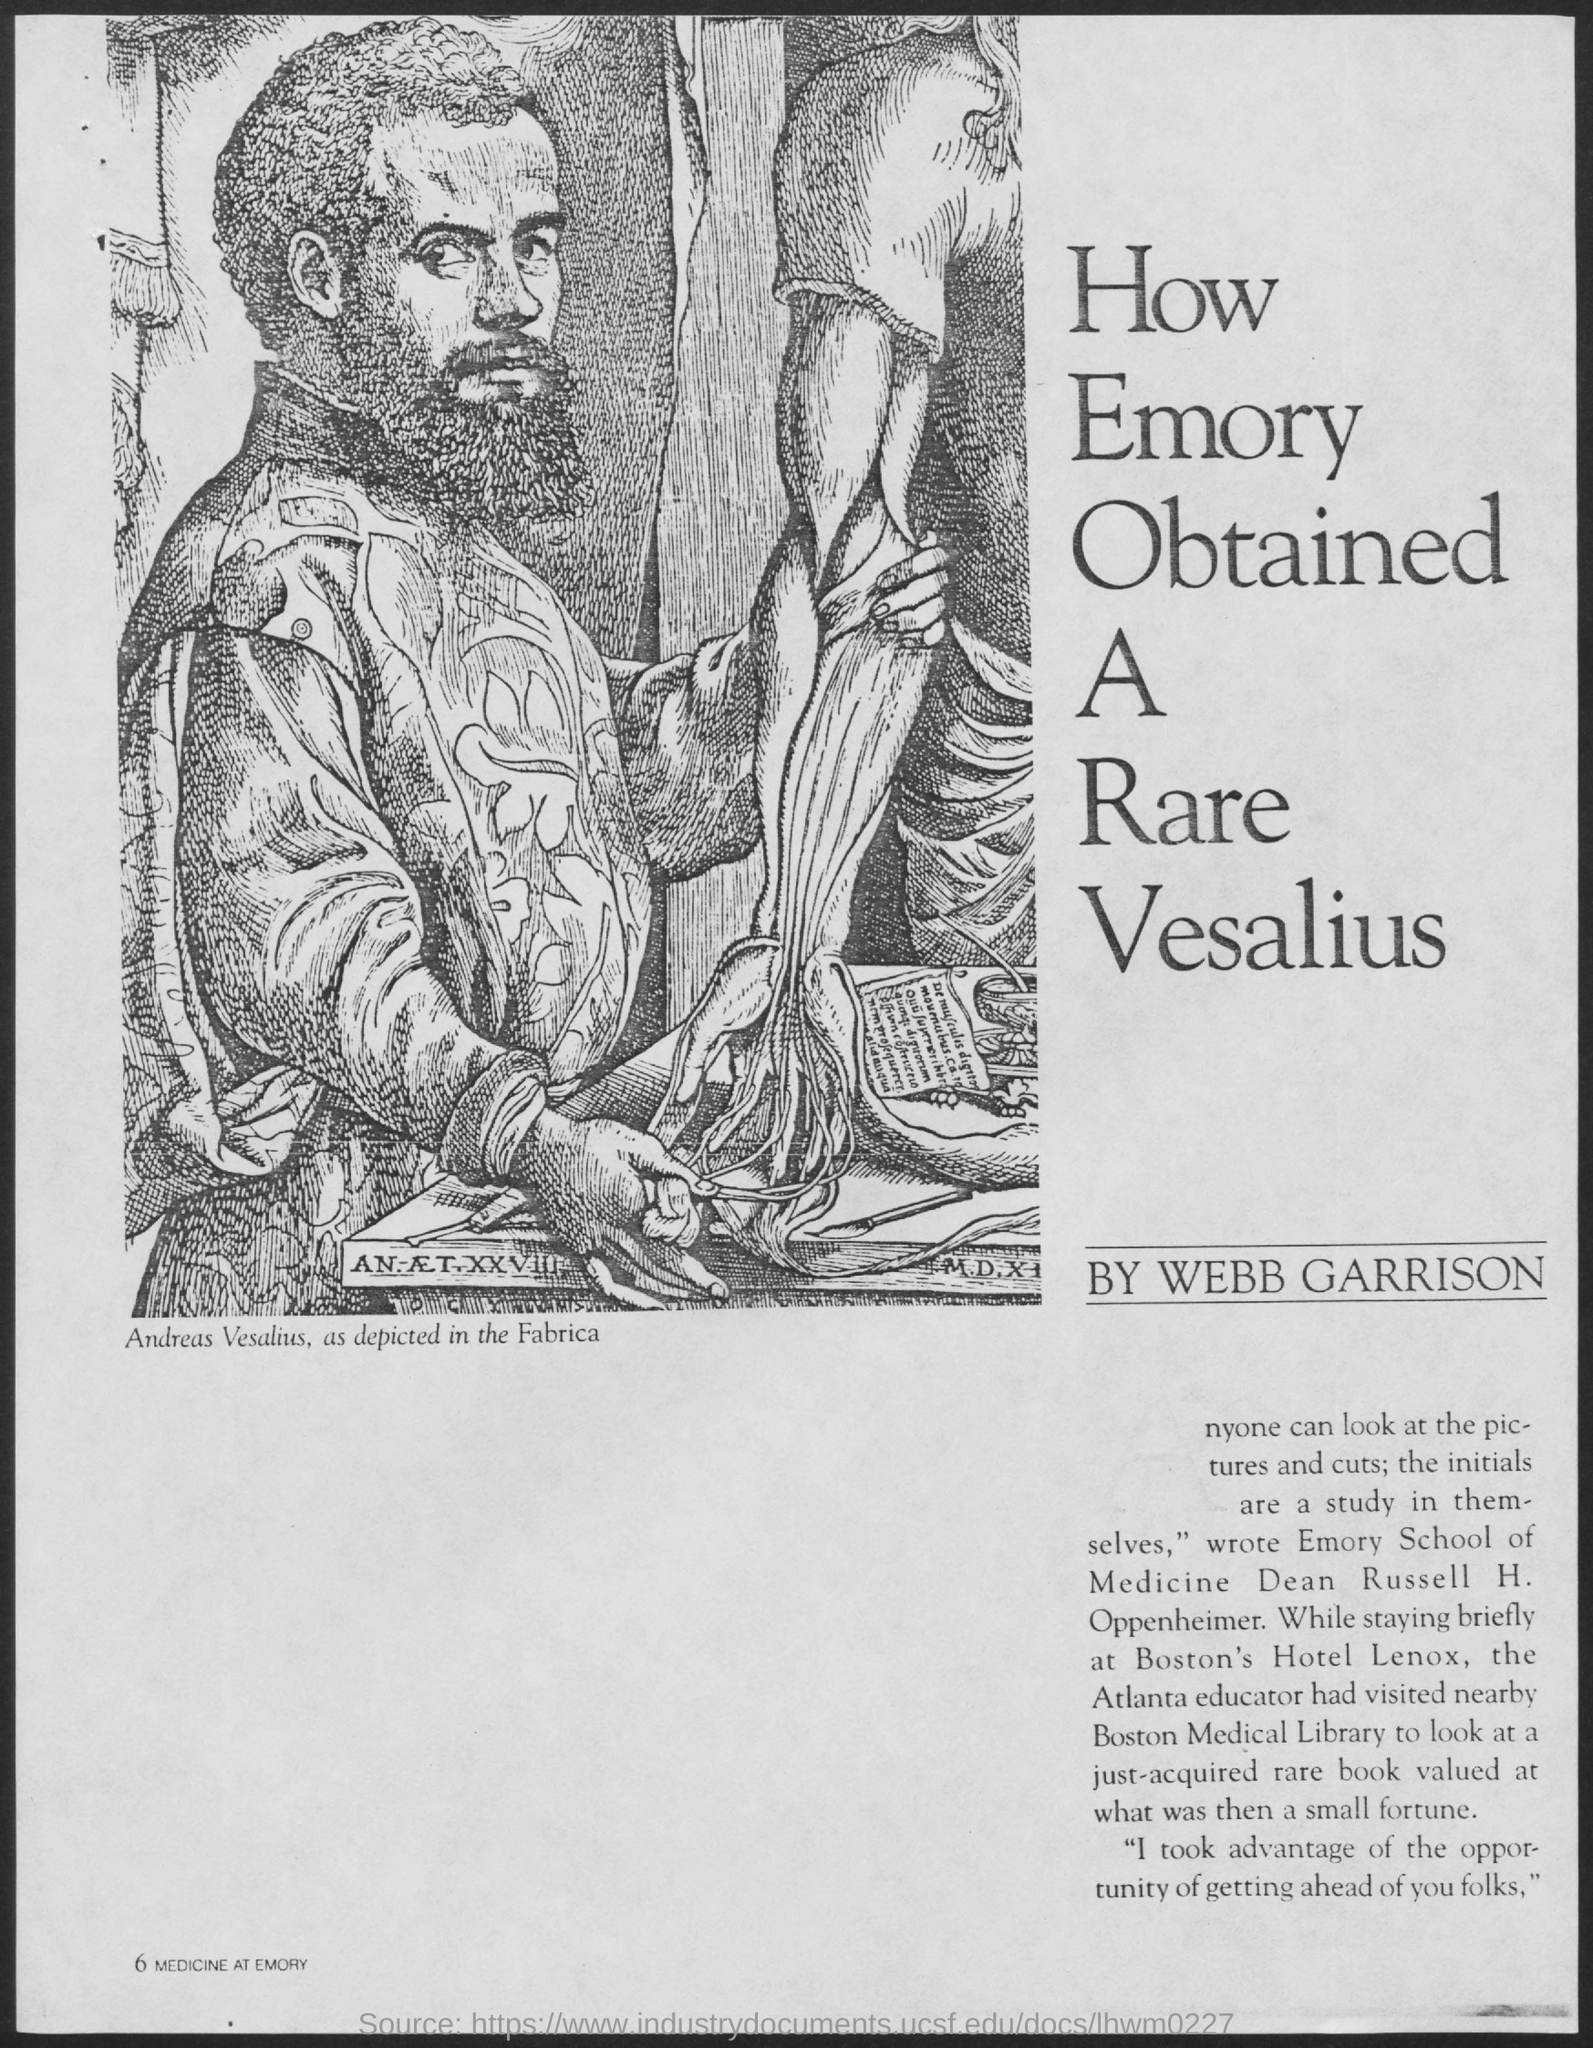Whose picture is shown?
Offer a terse response. Andreas Vesalius. Who was the Dean of Emory School of Medicine?
Keep it short and to the point. Russell H. Oppenheimer. Where did Russell visit while he stayed in Boston's Hotel Lenox?
Your answer should be compact. Boston Medical Library. 